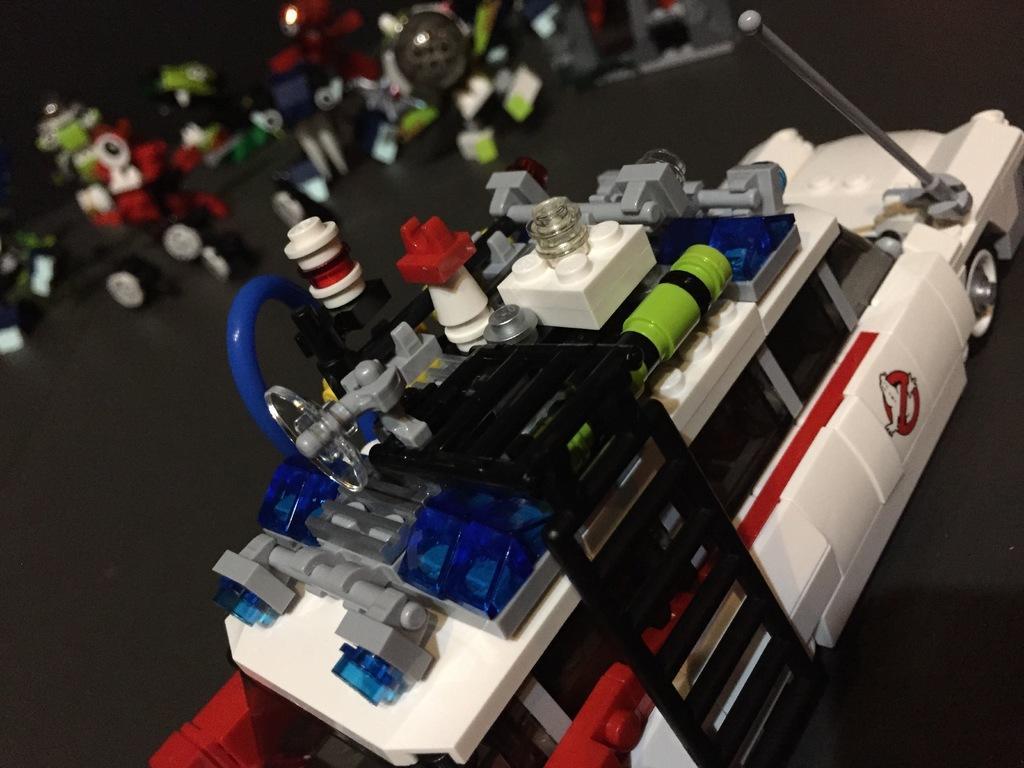Describe this image in one or two sentences. In this image I can see some colorful toys. 